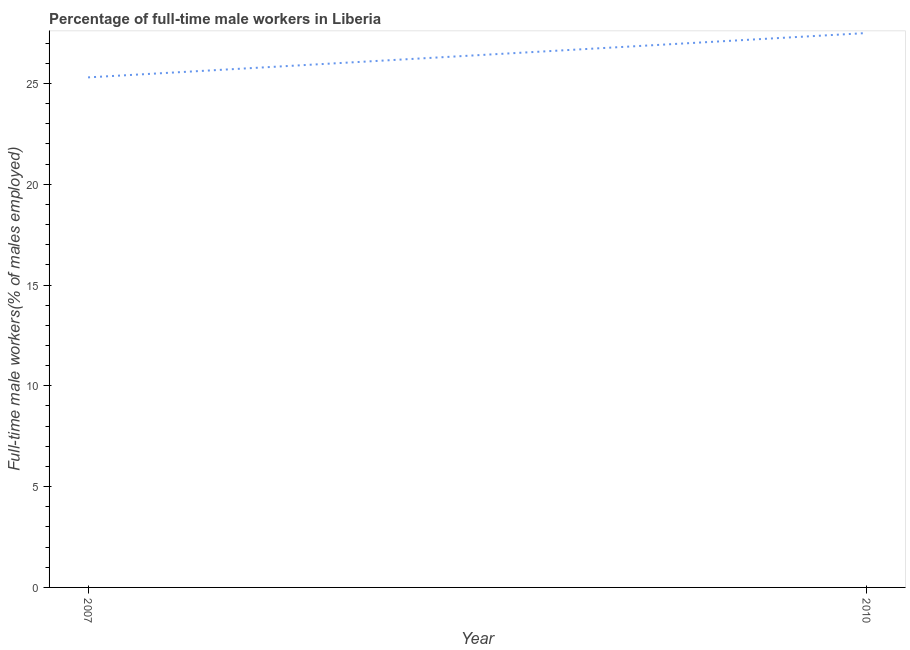What is the percentage of full-time male workers in 2010?
Keep it short and to the point. 27.5. Across all years, what is the maximum percentage of full-time male workers?
Your answer should be very brief. 27.5. Across all years, what is the minimum percentage of full-time male workers?
Ensure brevity in your answer.  25.3. In which year was the percentage of full-time male workers maximum?
Provide a succinct answer. 2010. What is the sum of the percentage of full-time male workers?
Make the answer very short. 52.8. What is the difference between the percentage of full-time male workers in 2007 and 2010?
Offer a very short reply. -2.2. What is the average percentage of full-time male workers per year?
Keep it short and to the point. 26.4. What is the median percentage of full-time male workers?
Provide a succinct answer. 26.4. Do a majority of the years between 2010 and 2007 (inclusive) have percentage of full-time male workers greater than 4 %?
Offer a very short reply. No. What is the ratio of the percentage of full-time male workers in 2007 to that in 2010?
Ensure brevity in your answer.  0.92. Is the percentage of full-time male workers in 2007 less than that in 2010?
Make the answer very short. Yes. In how many years, is the percentage of full-time male workers greater than the average percentage of full-time male workers taken over all years?
Make the answer very short. 1. Does the percentage of full-time male workers monotonically increase over the years?
Ensure brevity in your answer.  Yes. How many lines are there?
Provide a succinct answer. 1. What is the difference between two consecutive major ticks on the Y-axis?
Your answer should be compact. 5. Are the values on the major ticks of Y-axis written in scientific E-notation?
Provide a short and direct response. No. Does the graph contain grids?
Offer a terse response. No. What is the title of the graph?
Give a very brief answer. Percentage of full-time male workers in Liberia. What is the label or title of the X-axis?
Offer a terse response. Year. What is the label or title of the Y-axis?
Ensure brevity in your answer.  Full-time male workers(% of males employed). What is the Full-time male workers(% of males employed) of 2007?
Offer a terse response. 25.3. What is the Full-time male workers(% of males employed) of 2010?
Provide a succinct answer. 27.5. What is the ratio of the Full-time male workers(% of males employed) in 2007 to that in 2010?
Ensure brevity in your answer.  0.92. 